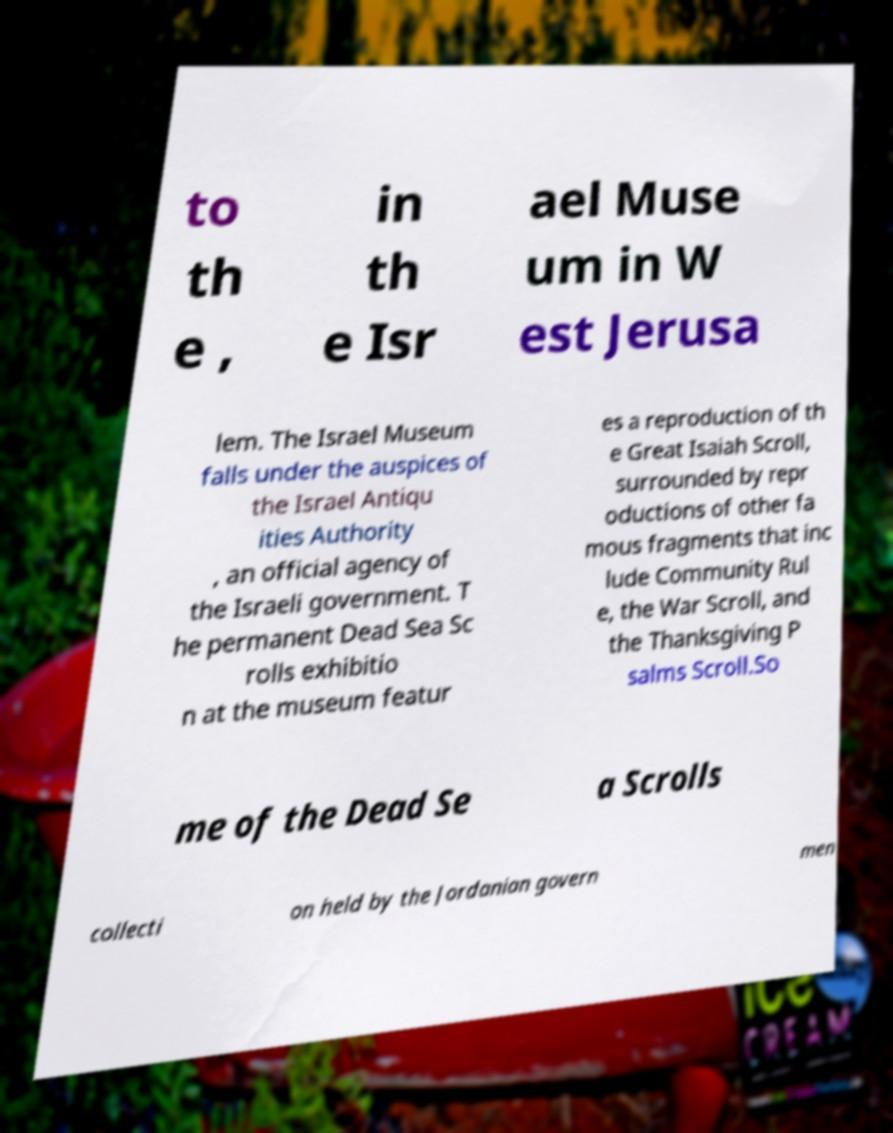Can you read and provide the text displayed in the image?This photo seems to have some interesting text. Can you extract and type it out for me? to th e , in th e Isr ael Muse um in W est Jerusa lem. The Israel Museum falls under the auspices of the Israel Antiqu ities Authority , an official agency of the Israeli government. T he permanent Dead Sea Sc rolls exhibitio n at the museum featur es a reproduction of th e Great Isaiah Scroll, surrounded by repr oductions of other fa mous fragments that inc lude Community Rul e, the War Scroll, and the Thanksgiving P salms Scroll.So me of the Dead Se a Scrolls collecti on held by the Jordanian govern men 